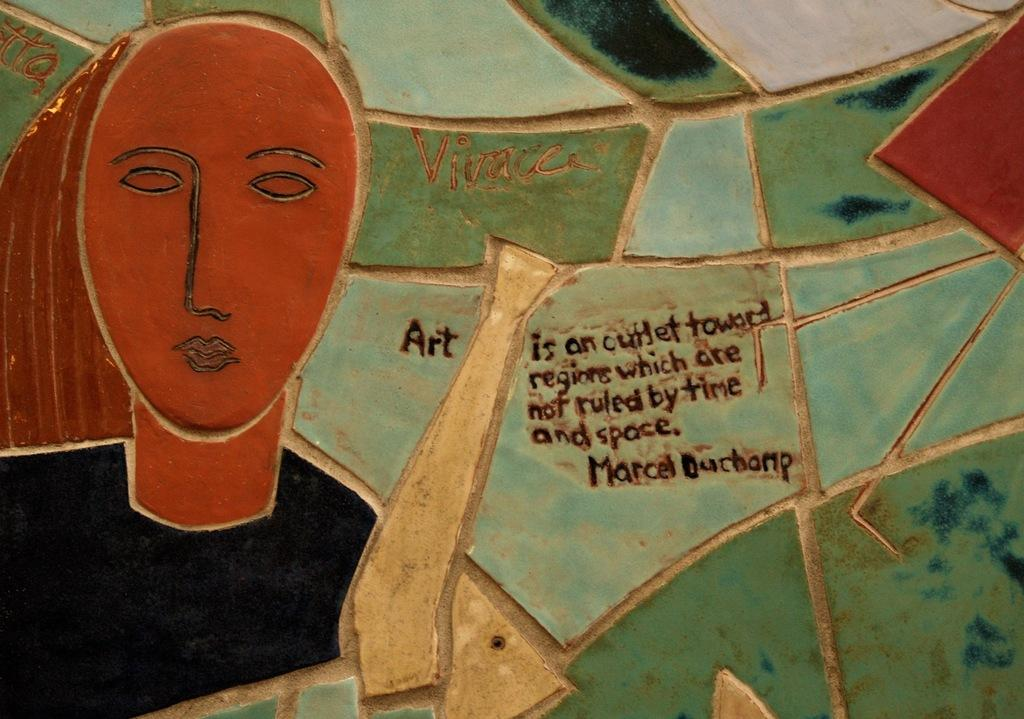What is the main feature in the center of the image? There is a wall in the center of the image. What can be found on the wall? There is text and a painting on the wall. What type of apparel is being protested in the image? There is no protest or apparel present in the image; it only features a wall with text and a painting. 